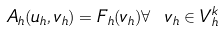<formula> <loc_0><loc_0><loc_500><loc_500>A _ { h } ( u _ { h } , v _ { h } ) = F _ { h } ( v _ { h } ) \forall \ v _ { h } \in V ^ { k } _ { h }</formula> 